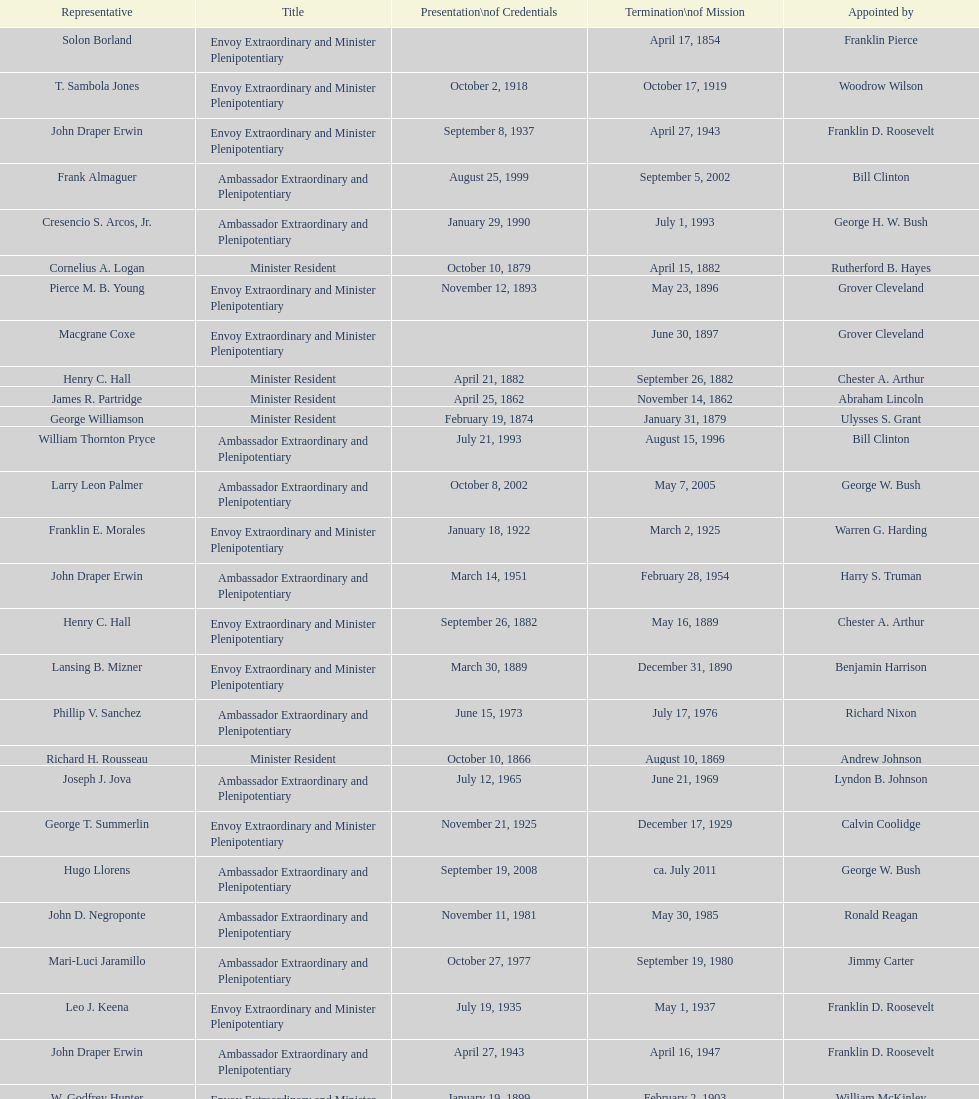Who was the last representative picked? Lisa Kubiske. 